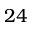Convert formula to latex. <formula><loc_0><loc_0><loc_500><loc_500>2 4</formula> 